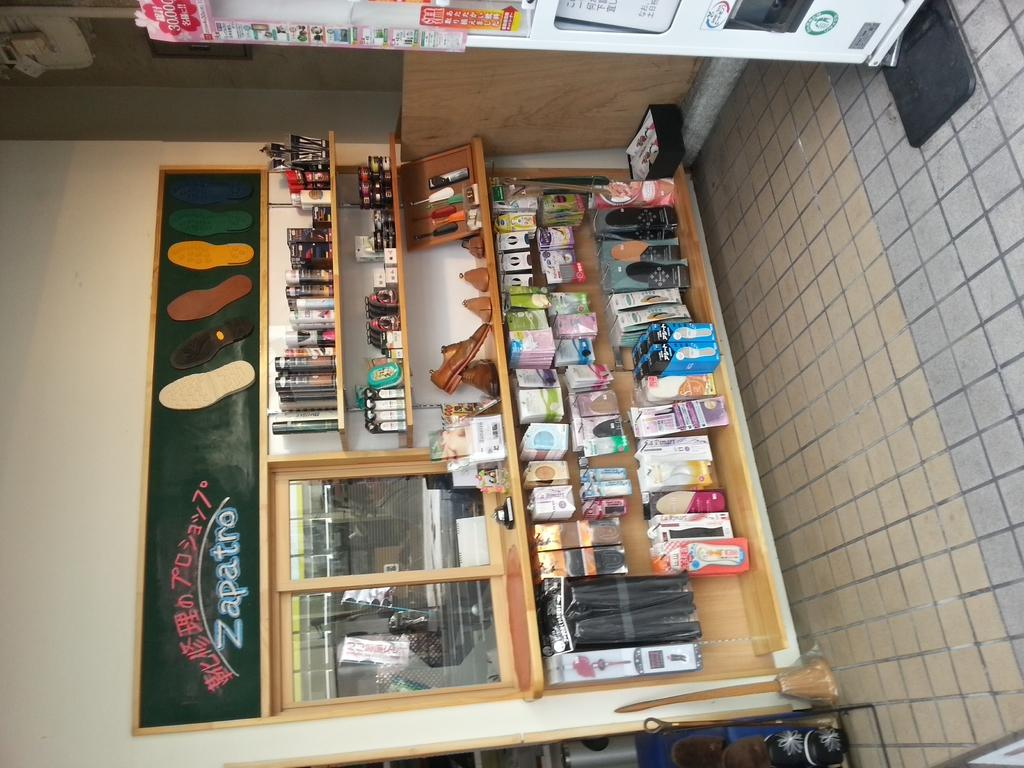<image>
Present a compact description of the photo's key features. a store with a chalboard with Zapatros drawn on it 